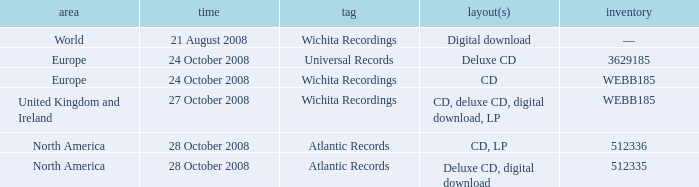Which catalog value has a region of world? —. 